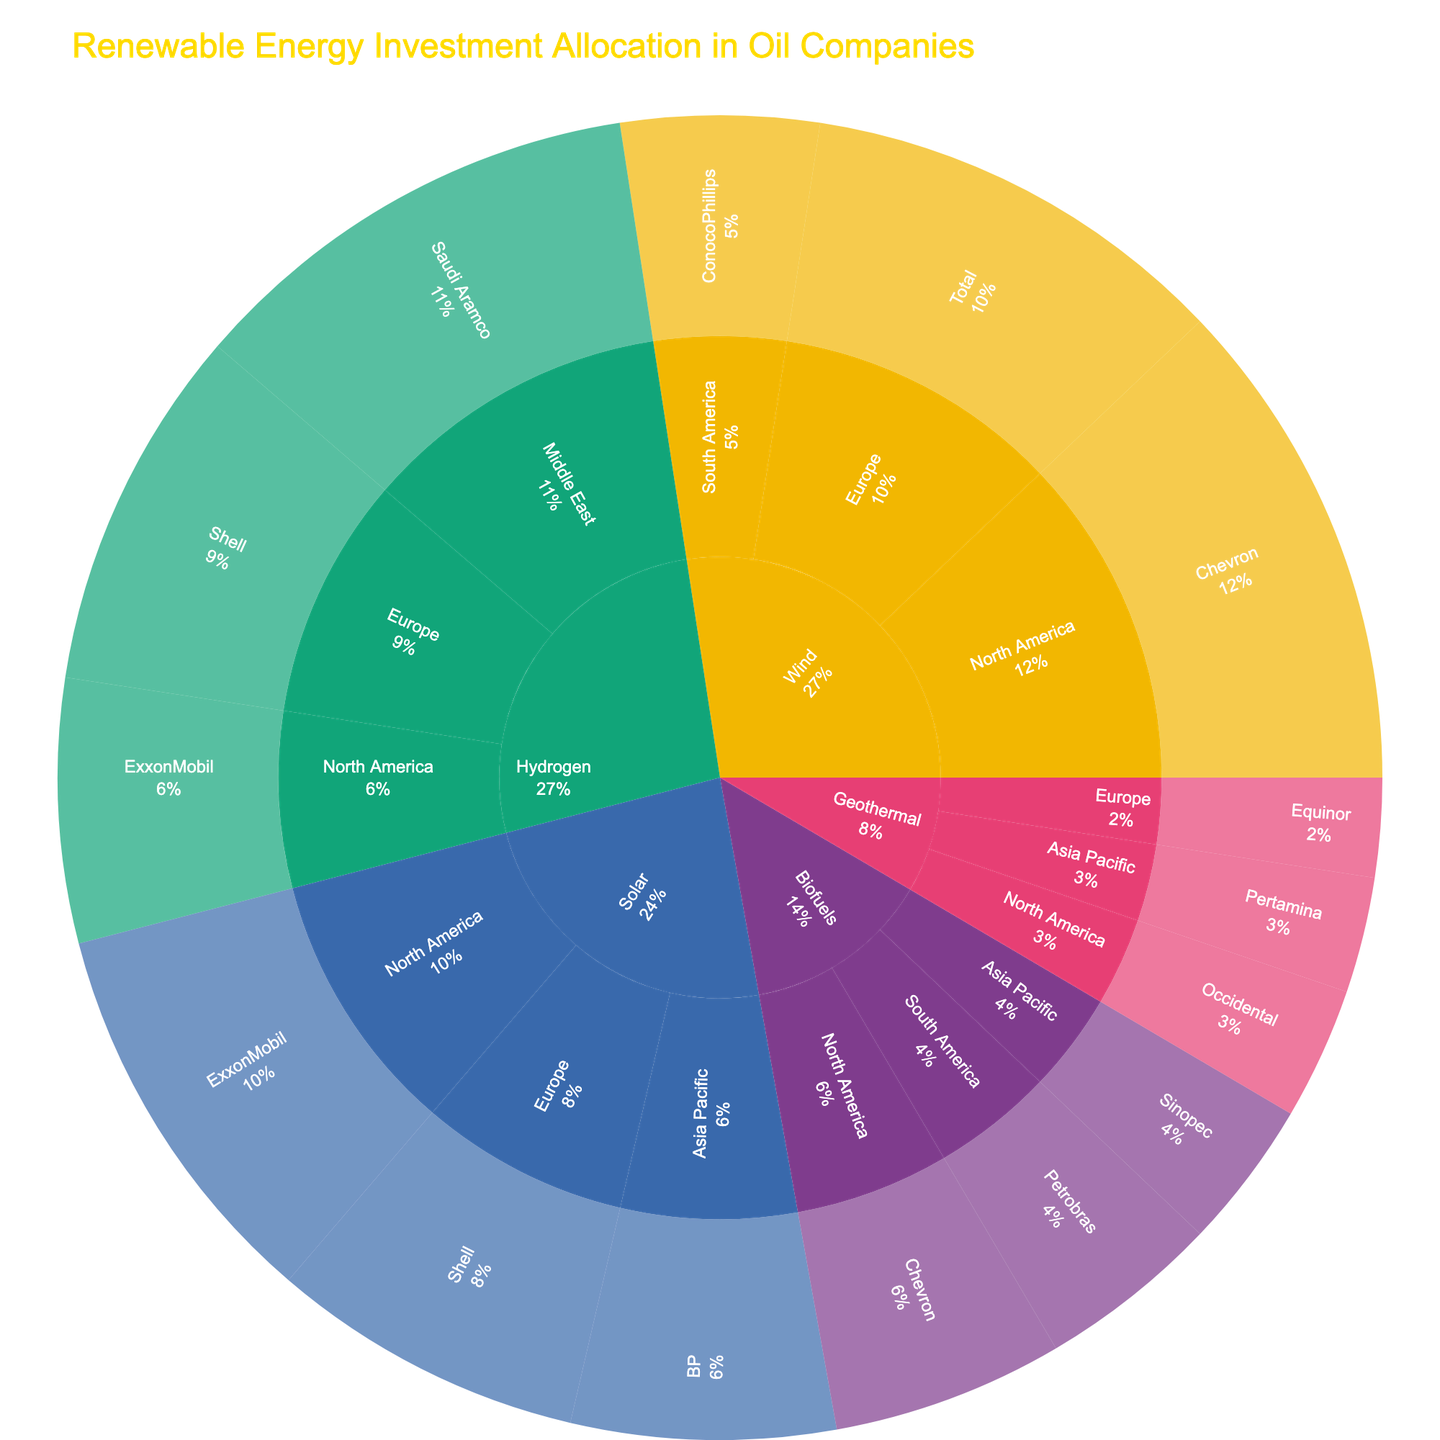Who has the largest investment in Wind technology? The largest investment in Wind technology is in North America by Chevron, with an investment of 1500 million dollars. This is visible in the Wind segment branching to North America and then Chevron, showing the highest value within the category.
Answer: Chevron Which region has the smallest investment in Geothermal technology? The smallest investment in Geothermal technology is in Europe by Equinor, with an investment of 300 million dollars. This can be observed in the Geothermal segment branching to Europe and then Equinor, showing the smallest value within the category.
Answer: Europe What is the total investment in Solar technology across all companies? The total investment in Solar technology is the sum of investments by ExxonMobil, Shell, and BP. Adding these amounts: 1200 (ExxonMobil) + 950 (Shell) + 800 (BP) = 2950 million dollars.
Answer: 2950 How much more has been invested in Hydrogen technology than in Biofuels? The total investment in Hydrogen is 3300 million dollars (800 + 1100 + 1400). The total investment in Biofuels is 1700 million dollars (700 + 550 + 450). The difference is 3300 - 1700 = 1600 million dollars.
Answer: 1600 Which technology received the highest total investment? Adding up the investments for each technology: Solar (2950), Wind (3400), Hydrogen (3300), Biofuels (1700), and Geothermal (1050). Wind has the highest total investment.
Answer: Wind Which company in North America has the highest investment across all technologies? Chevron has the highest investment in North America with a 1500 million dollar investment in Wind technology, which is visible in the plot.
Answer: Chevron What is the average investment amount in Geothermal technology? The investments in Geothermal are 400 (North America), 350 (Asia Pacific), and 300 (Europe). The average is (400 + 350 + 300) / 3 = 1050 / 3 = 350 million dollars.
Answer: 350 Compare the investments in Biofuels by Sinopec and Petrobras. Which is higher? Sinopec has invested 450 million dollars and Petrobras has invested 550 million dollars in Biofuels. Therefore, Petrobras has a higher investment.
Answer: Petrobras 